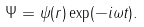<formula> <loc_0><loc_0><loc_500><loc_500>\Psi = \psi ( r ) \exp ( - i \omega t ) .</formula> 